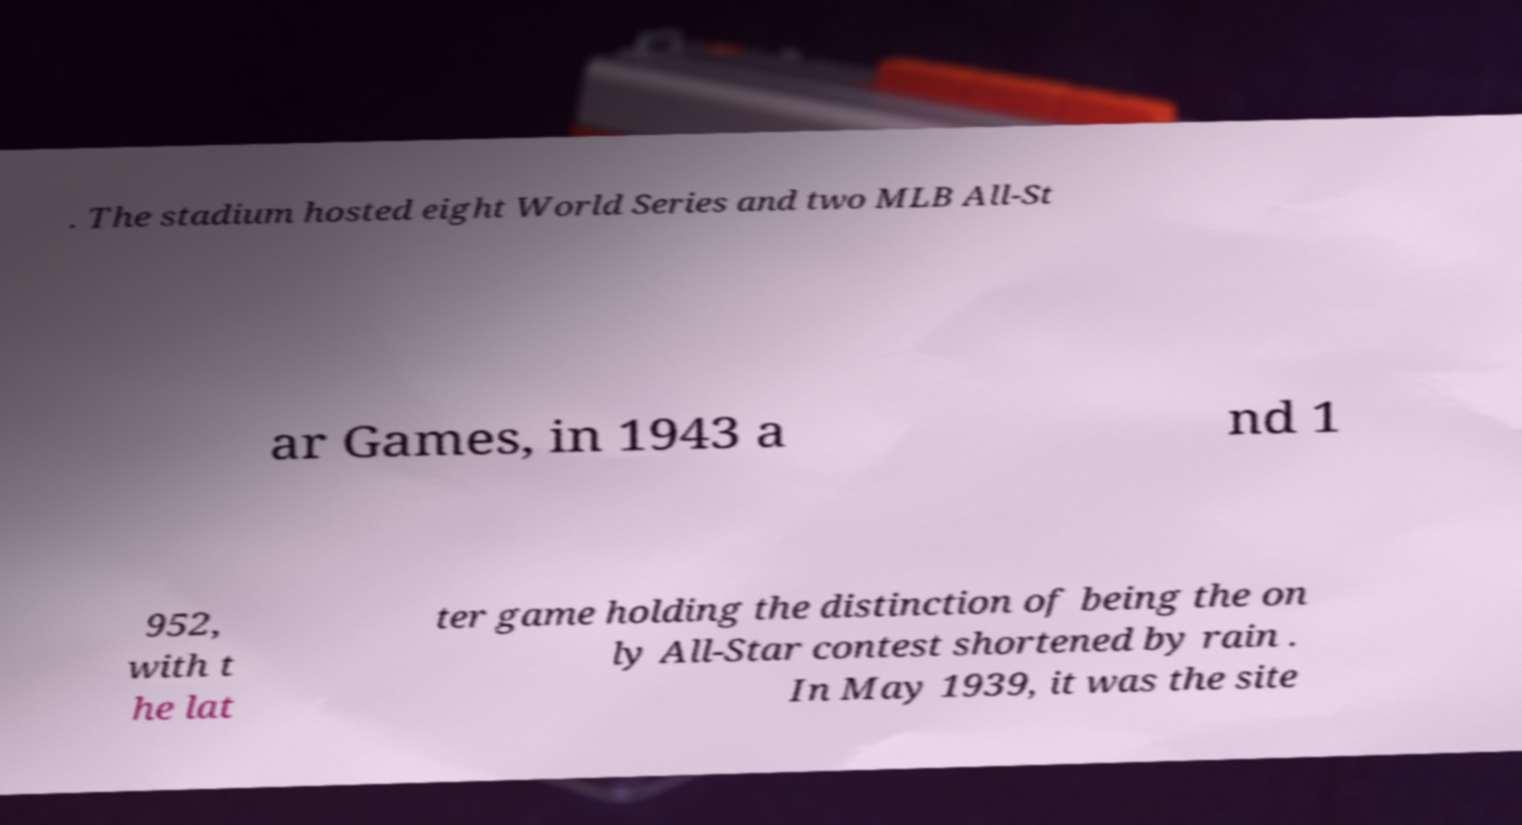Please identify and transcribe the text found in this image. . The stadium hosted eight World Series and two MLB All-St ar Games, in 1943 a nd 1 952, with t he lat ter game holding the distinction of being the on ly All-Star contest shortened by rain . In May 1939, it was the site 